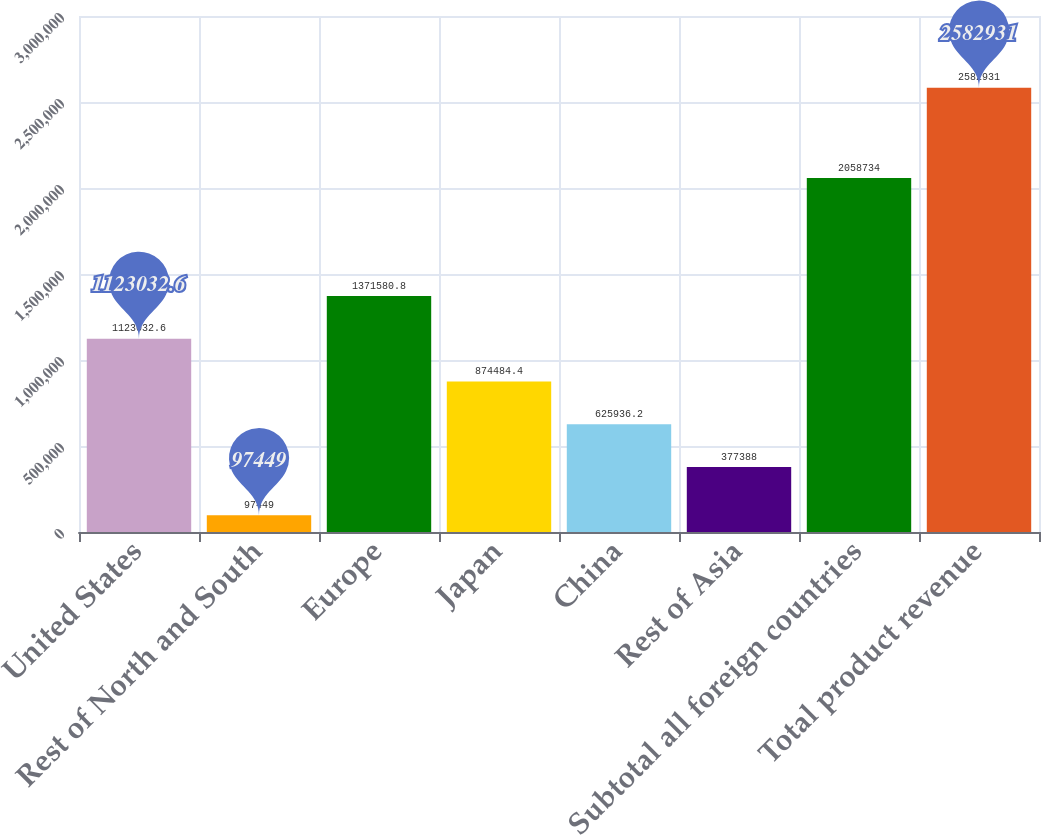<chart> <loc_0><loc_0><loc_500><loc_500><bar_chart><fcel>United States<fcel>Rest of North and South<fcel>Europe<fcel>Japan<fcel>China<fcel>Rest of Asia<fcel>Subtotal all foreign countries<fcel>Total product revenue<nl><fcel>1.12303e+06<fcel>97449<fcel>1.37158e+06<fcel>874484<fcel>625936<fcel>377388<fcel>2.05873e+06<fcel>2.58293e+06<nl></chart> 